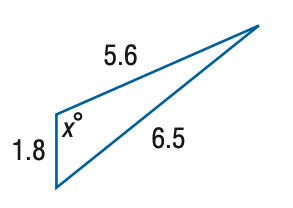Answer the mathemtical geometry problem and directly provide the correct option letter.
Question: Find x. Round the angle measure to the nearest degree.
Choices: A: 108 B: 112 C: 116 D: 120 B 